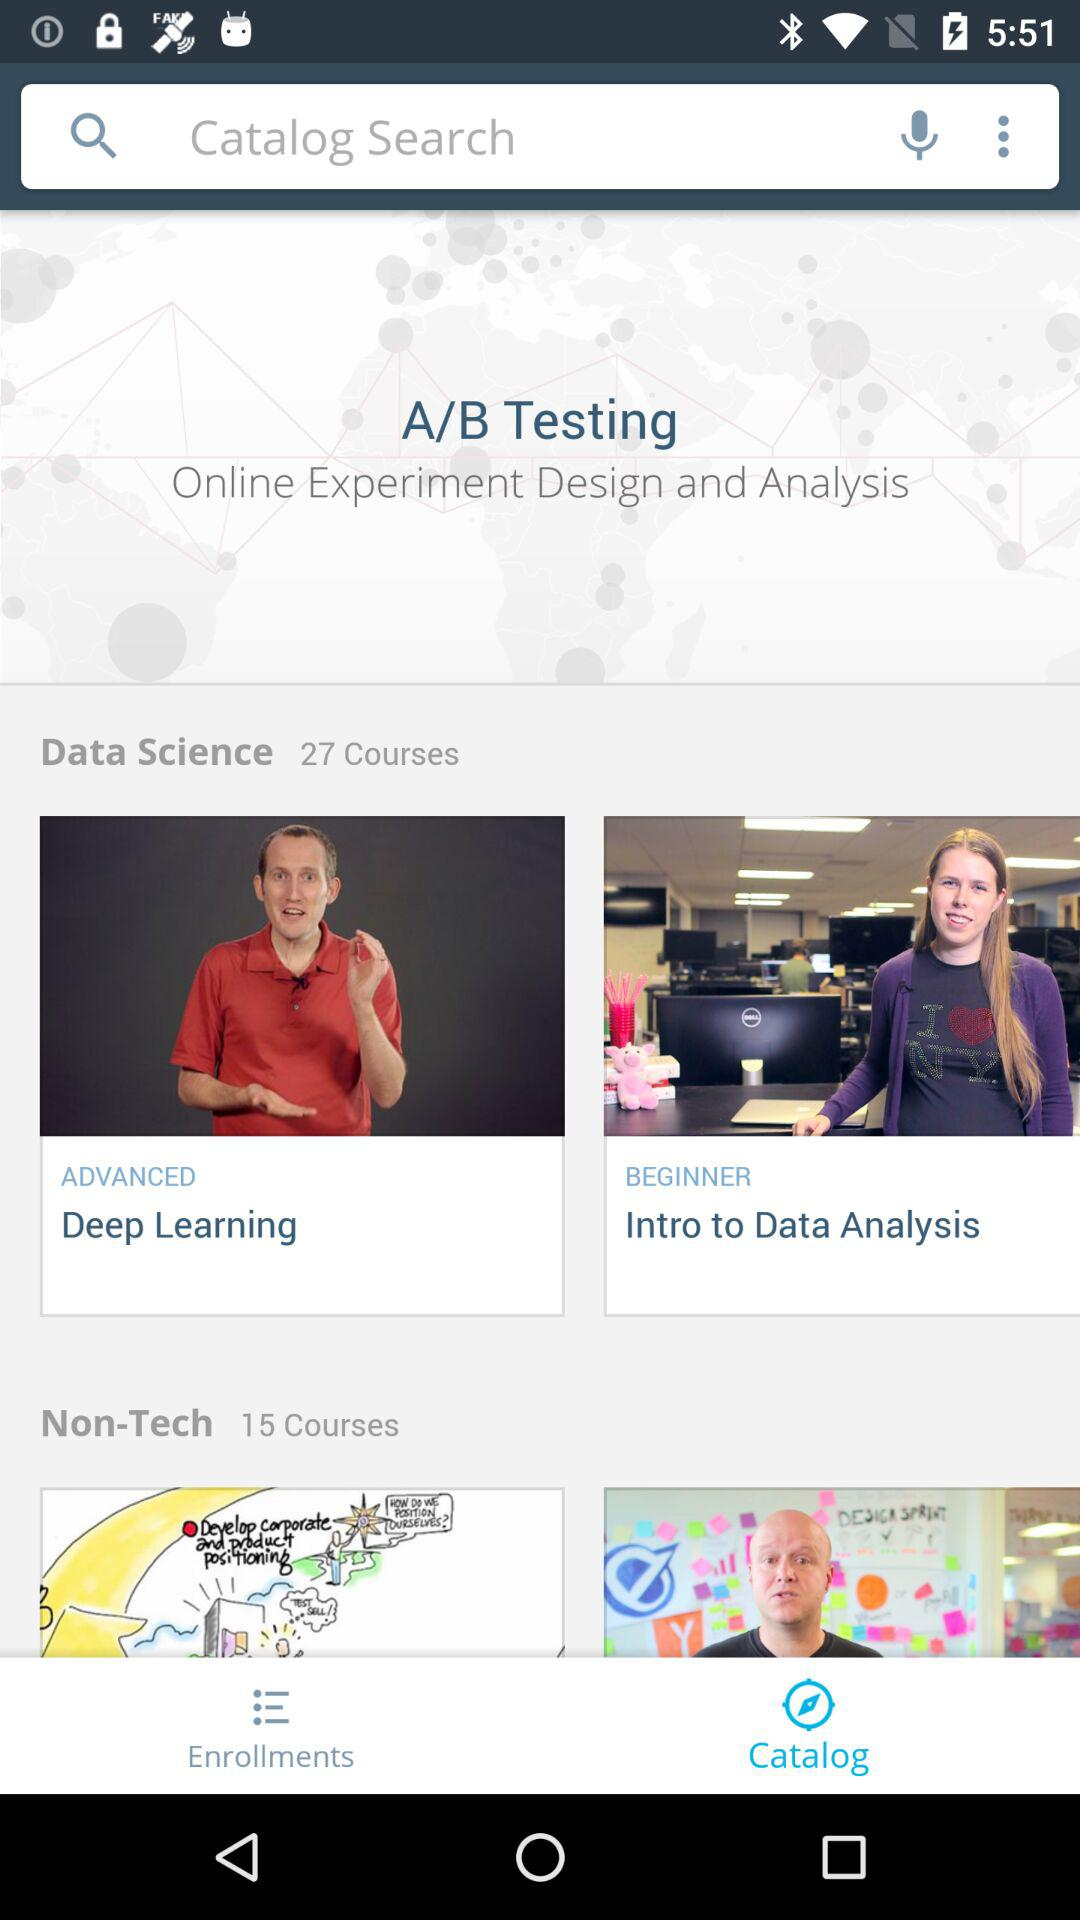How many courses are there in total?
Answer the question using a single word or phrase. 42 